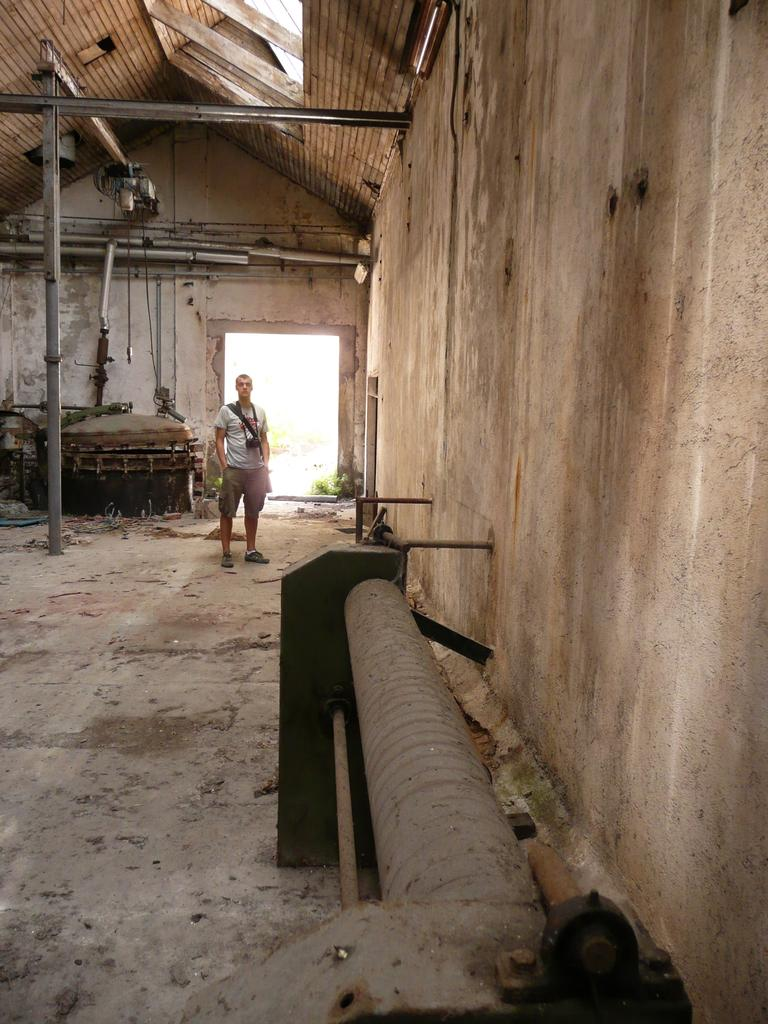What is the man in the image doing? The man is standing in the image. What is the man carrying in the image? The man is carrying a camera in the image. What type of structure can be seen in the image? There are walls visible in the image. What objects can be seen in the image? There are objects visible in the image, including a pipe and rods. What type of silk fabric is draped over the man's suit in the image? There is no silk fabric or suit present in the image. 